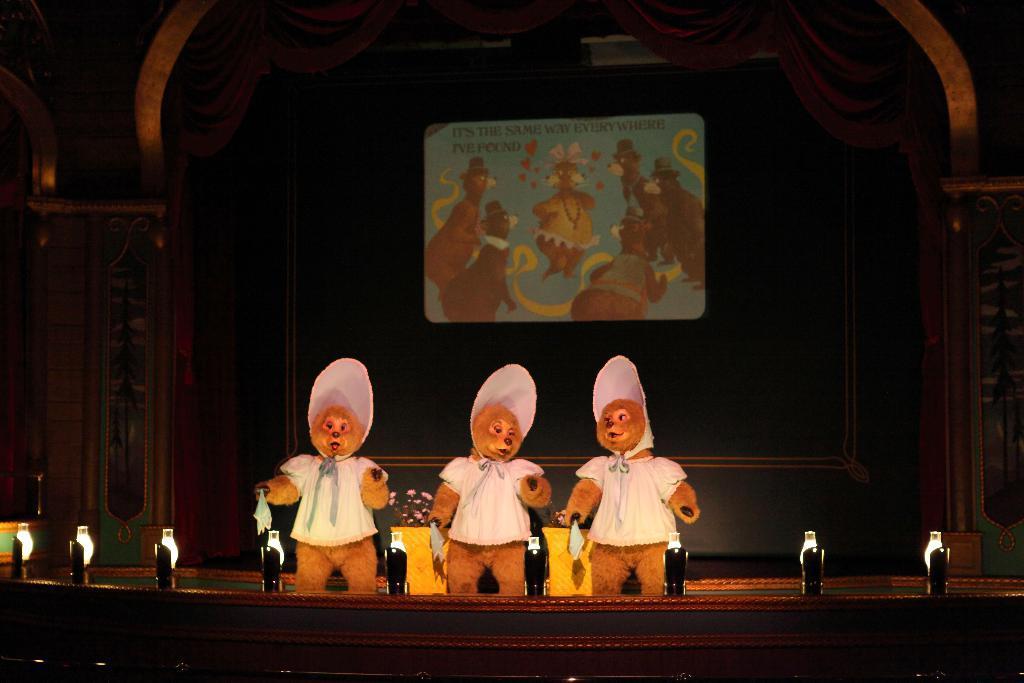In one or two sentences, can you explain what this image depicts? In this image there are three persons wearing different costumes standing on the stage. In the background there is a screen attached to the wall. 